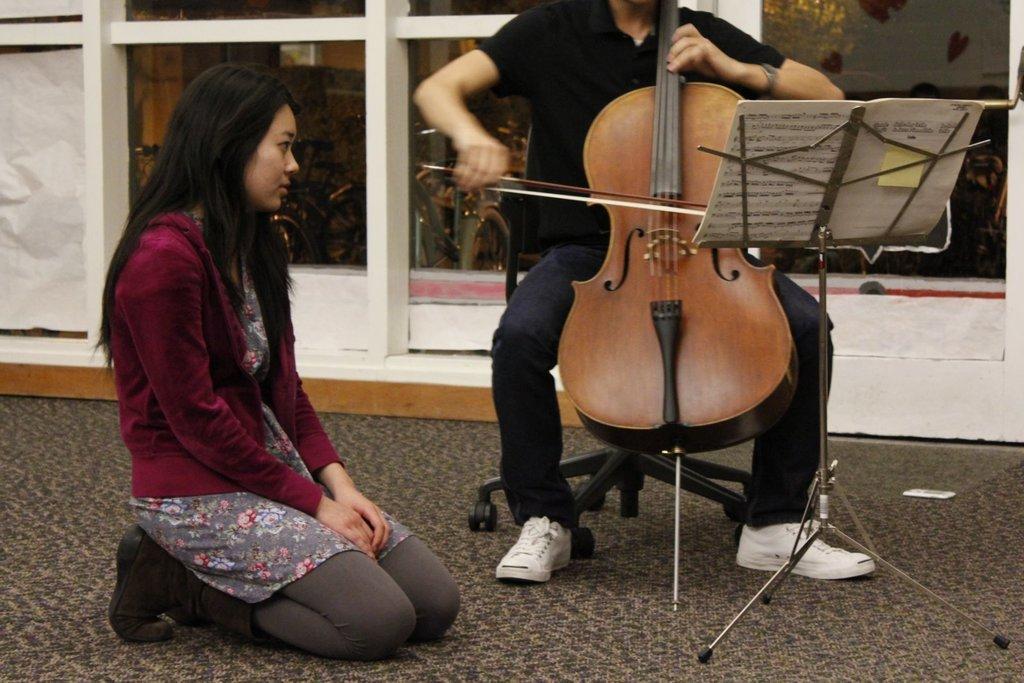How would you summarize this image in a sentence or two? In this image i can see a person playing guitar and the other person sitting on floor there is a book and the stand at the back ground i can see a plant. 